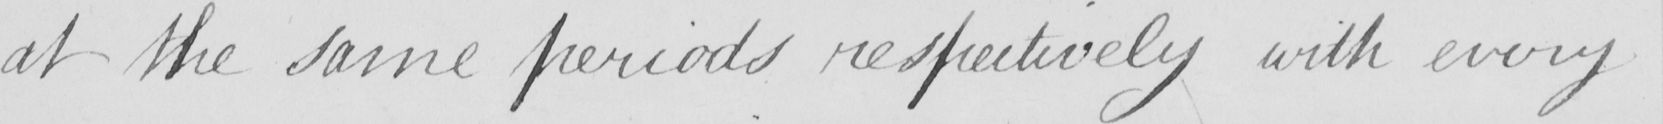What does this handwritten line say? at the same periods respectively with every 